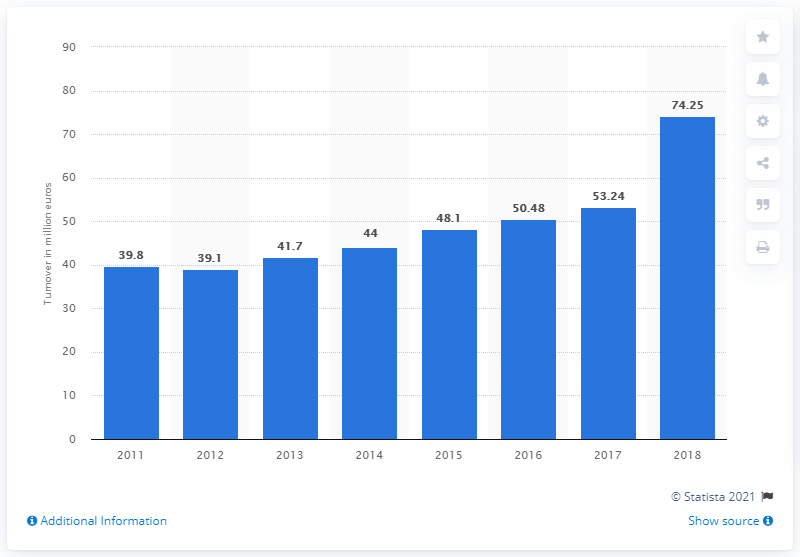Indicate a few pertinent items in this graphic. The turnover of Moschino S.p.A. in 2012 was 39.8 million euros. 